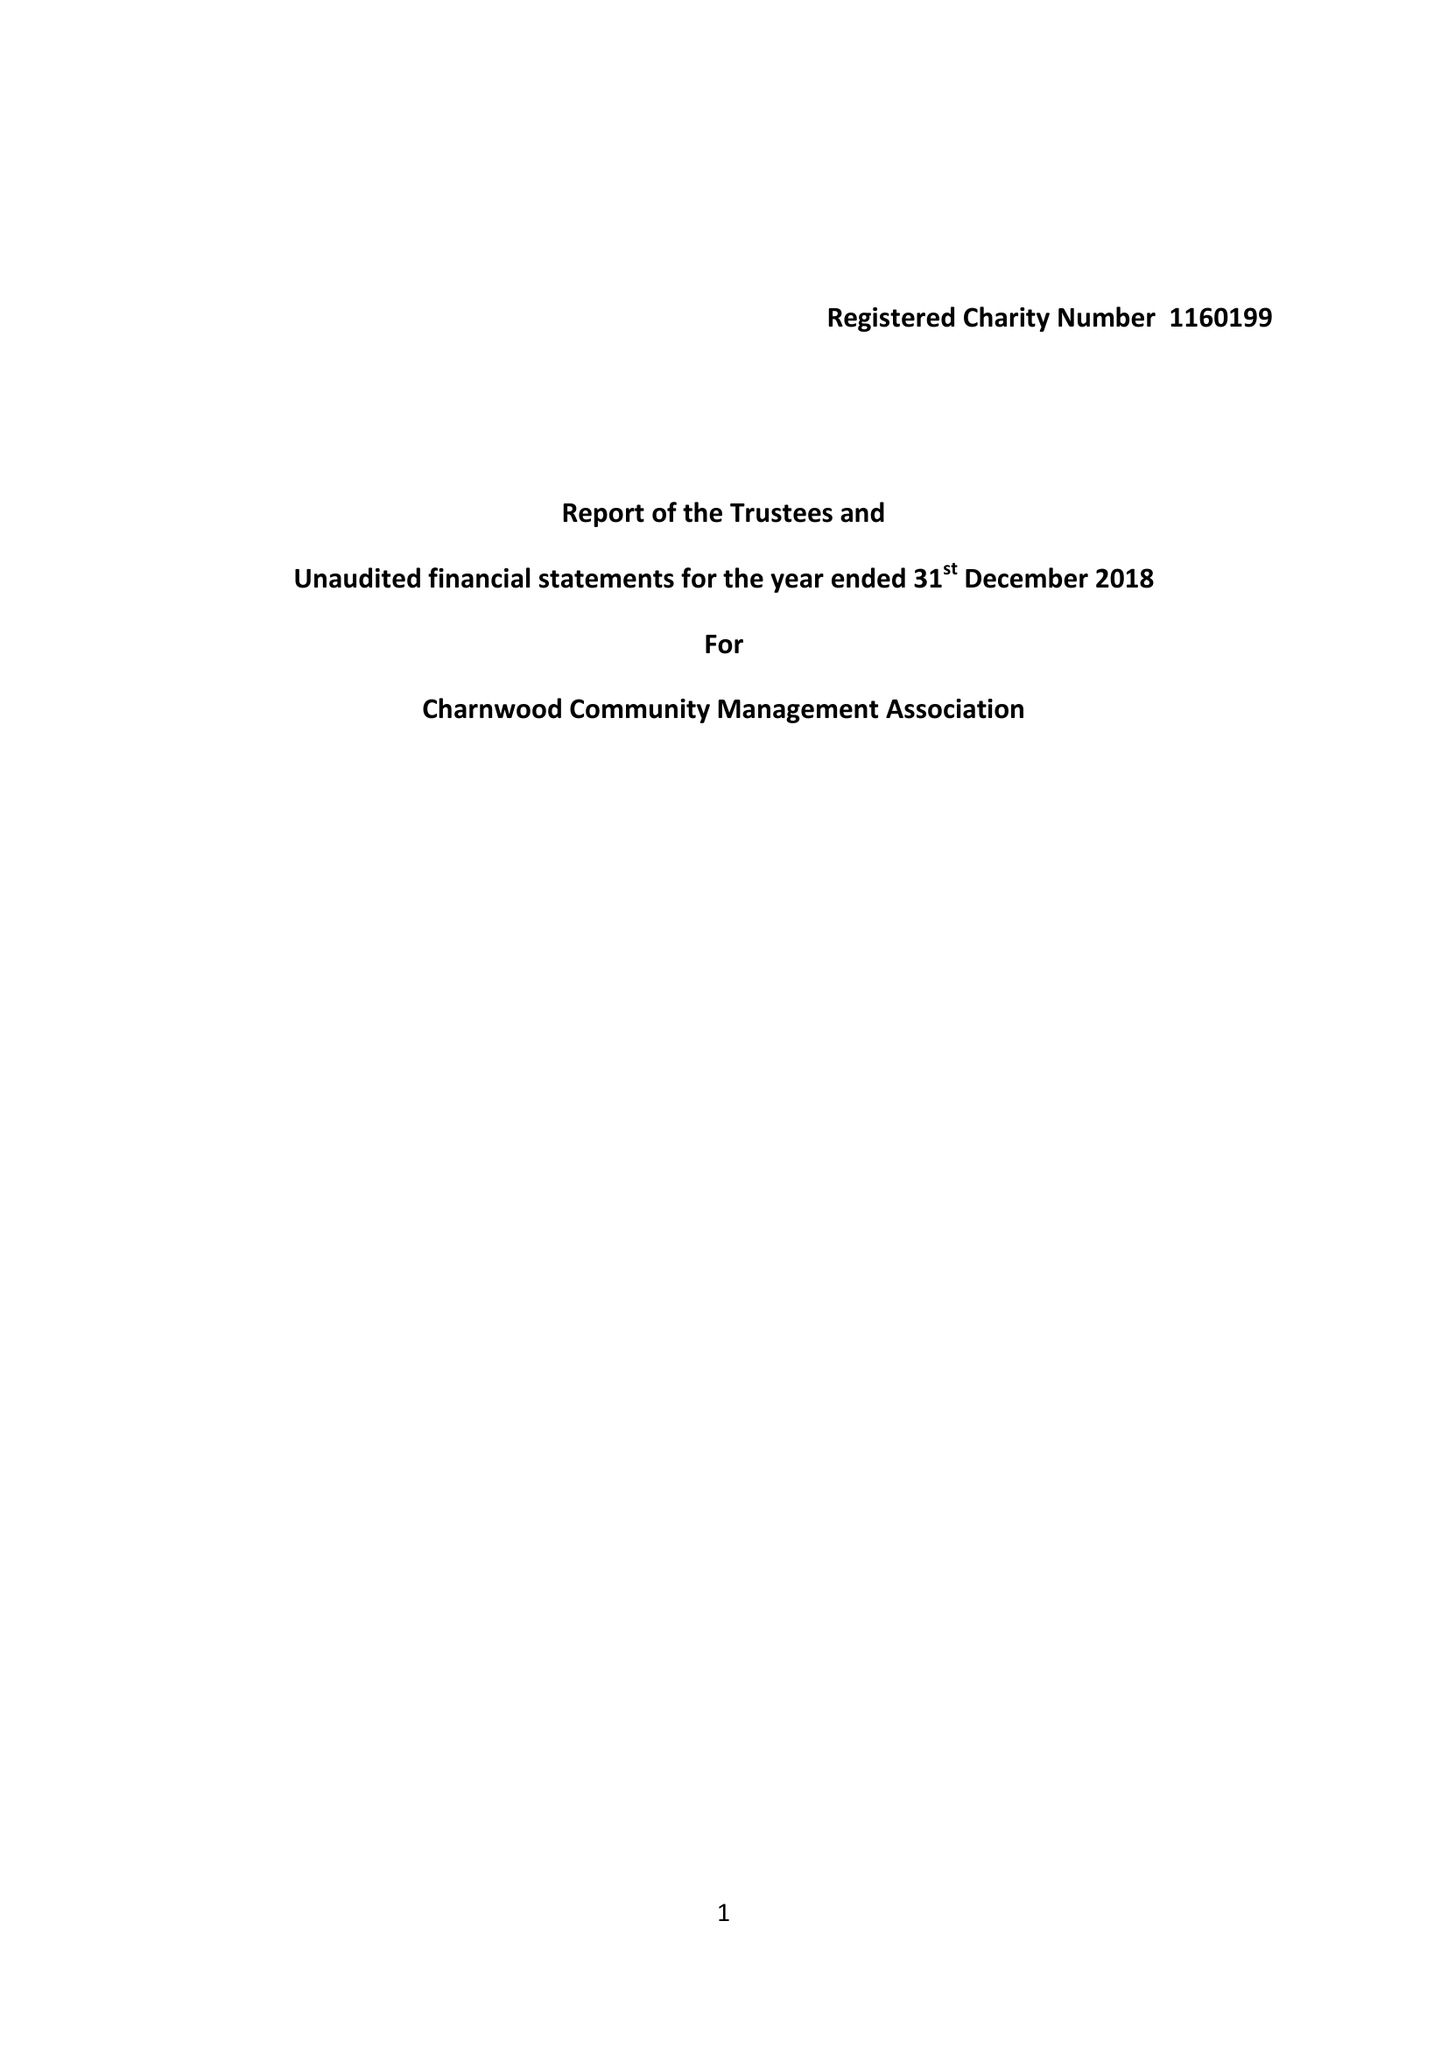What is the value for the report_date?
Answer the question using a single word or phrase. 2018-12-31 